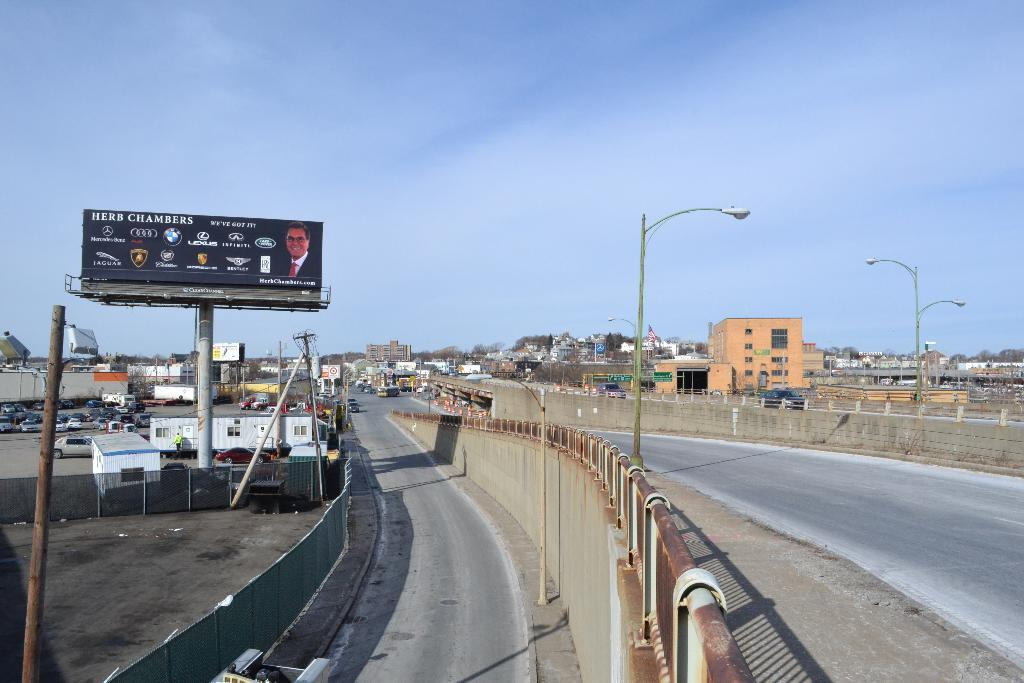<image>
Relay a brief, clear account of the picture shown. A Herb Chambers billboard features many car company logos on it. 